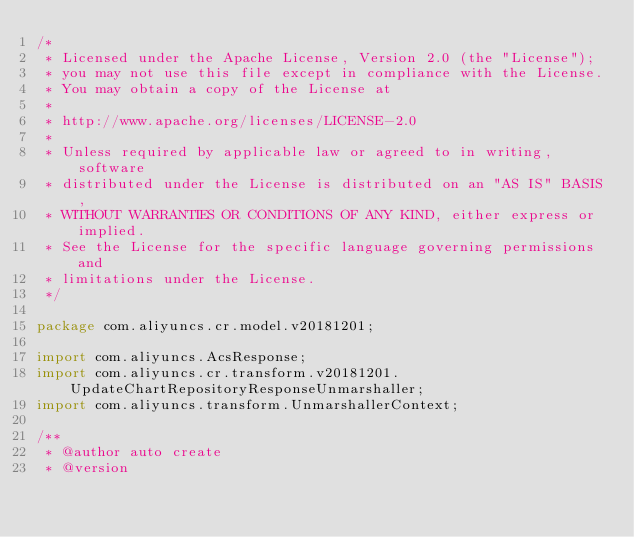<code> <loc_0><loc_0><loc_500><loc_500><_Java_>/*
 * Licensed under the Apache License, Version 2.0 (the "License");
 * you may not use this file except in compliance with the License.
 * You may obtain a copy of the License at
 *
 * http://www.apache.org/licenses/LICENSE-2.0
 *
 * Unless required by applicable law or agreed to in writing, software
 * distributed under the License is distributed on an "AS IS" BASIS,
 * WITHOUT WARRANTIES OR CONDITIONS OF ANY KIND, either express or implied.
 * See the License for the specific language governing permissions and
 * limitations under the License.
 */

package com.aliyuncs.cr.model.v20181201;

import com.aliyuncs.AcsResponse;
import com.aliyuncs.cr.transform.v20181201.UpdateChartRepositoryResponseUnmarshaller;
import com.aliyuncs.transform.UnmarshallerContext;

/**
 * @author auto create
 * @version </code> 